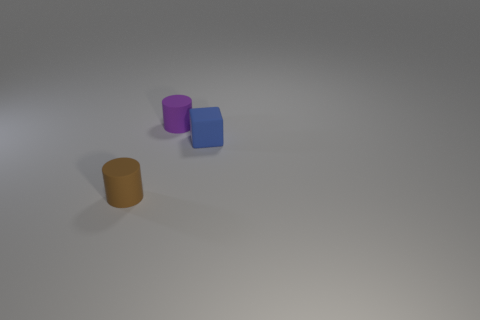There is a tiny matte object that is both in front of the small purple rubber cylinder and on the left side of the small cube; what color is it?
Your answer should be compact. Brown. How many other things are there of the same shape as the small blue rubber thing?
Your response must be concise. 0. What is the color of the block that is the same size as the purple thing?
Make the answer very short. Blue. There is a tiny cylinder in front of the small purple matte cylinder; what is its color?
Offer a very short reply. Brown. Are there any blue matte blocks on the left side of the rubber cylinder to the left of the purple thing?
Keep it short and to the point. No. There is a small purple rubber object; is it the same shape as the rubber thing in front of the matte block?
Ensure brevity in your answer.  Yes. Are there any things that have the same material as the block?
Offer a very short reply. Yes. The cylinder that is behind the tiny rubber cylinder in front of the blue rubber object is made of what material?
Your response must be concise. Rubber. What size is the purple thing that is the same material as the tiny block?
Offer a terse response. Small. What shape is the tiny purple rubber object that is on the right side of the brown cylinder?
Give a very brief answer. Cylinder. 